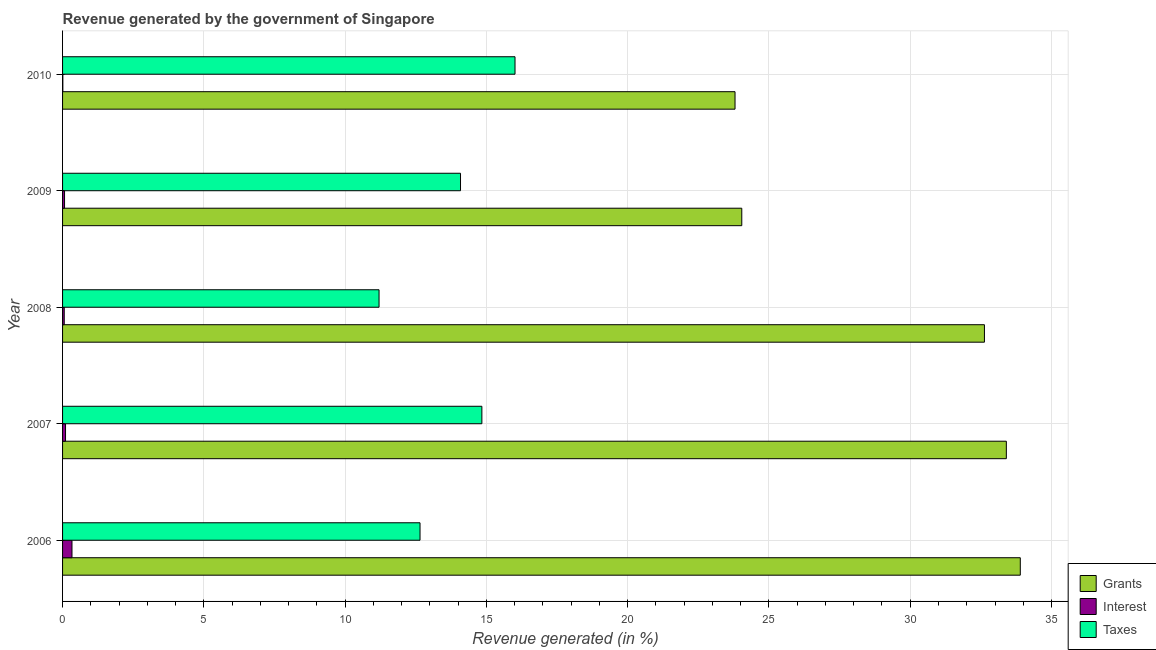How many different coloured bars are there?
Give a very brief answer. 3. What is the label of the 2nd group of bars from the top?
Give a very brief answer. 2009. What is the percentage of revenue generated by taxes in 2007?
Offer a very short reply. 14.84. Across all years, what is the maximum percentage of revenue generated by grants?
Offer a terse response. 33.89. Across all years, what is the minimum percentage of revenue generated by grants?
Make the answer very short. 23.8. In which year was the percentage of revenue generated by grants minimum?
Your answer should be compact. 2010. What is the total percentage of revenue generated by interest in the graph?
Provide a short and direct response. 0.58. What is the difference between the percentage of revenue generated by taxes in 2006 and that in 2010?
Provide a succinct answer. -3.36. What is the difference between the percentage of revenue generated by taxes in 2006 and the percentage of revenue generated by grants in 2008?
Your response must be concise. -19.98. What is the average percentage of revenue generated by grants per year?
Your answer should be very brief. 29.55. In the year 2010, what is the difference between the percentage of revenue generated by taxes and percentage of revenue generated by grants?
Provide a succinct answer. -7.79. In how many years, is the percentage of revenue generated by grants greater than 27 %?
Keep it short and to the point. 3. What is the ratio of the percentage of revenue generated by interest in 2007 to that in 2008?
Offer a terse response. 1.78. Is the percentage of revenue generated by interest in 2007 less than that in 2010?
Provide a succinct answer. No. What is the difference between the highest and the second highest percentage of revenue generated by grants?
Provide a short and direct response. 0.49. What is the difference between the highest and the lowest percentage of revenue generated by grants?
Your response must be concise. 10.1. In how many years, is the percentage of revenue generated by grants greater than the average percentage of revenue generated by grants taken over all years?
Keep it short and to the point. 3. Is the sum of the percentage of revenue generated by interest in 2009 and 2010 greater than the maximum percentage of revenue generated by taxes across all years?
Provide a short and direct response. No. What does the 3rd bar from the top in 2010 represents?
Your answer should be very brief. Grants. What does the 2nd bar from the bottom in 2008 represents?
Your answer should be compact. Interest. Are all the bars in the graph horizontal?
Ensure brevity in your answer.  Yes. How many years are there in the graph?
Offer a very short reply. 5. Does the graph contain any zero values?
Make the answer very short. No. Does the graph contain grids?
Provide a succinct answer. Yes. Where does the legend appear in the graph?
Your answer should be very brief. Bottom right. What is the title of the graph?
Keep it short and to the point. Revenue generated by the government of Singapore. What is the label or title of the X-axis?
Provide a short and direct response. Revenue generated (in %). What is the Revenue generated (in %) of Grants in 2006?
Provide a short and direct response. 33.89. What is the Revenue generated (in %) in Interest in 2006?
Provide a succinct answer. 0.33. What is the Revenue generated (in %) of Taxes in 2006?
Keep it short and to the point. 12.65. What is the Revenue generated (in %) of Grants in 2007?
Provide a succinct answer. 33.4. What is the Revenue generated (in %) in Interest in 2007?
Offer a very short reply. 0.1. What is the Revenue generated (in %) in Taxes in 2007?
Keep it short and to the point. 14.84. What is the Revenue generated (in %) of Grants in 2008?
Provide a short and direct response. 32.63. What is the Revenue generated (in %) of Interest in 2008?
Your response must be concise. 0.06. What is the Revenue generated (in %) in Taxes in 2008?
Your answer should be compact. 11.2. What is the Revenue generated (in %) in Grants in 2009?
Make the answer very short. 24.04. What is the Revenue generated (in %) in Interest in 2009?
Provide a short and direct response. 0.07. What is the Revenue generated (in %) in Taxes in 2009?
Provide a succinct answer. 14.08. What is the Revenue generated (in %) in Grants in 2010?
Make the answer very short. 23.8. What is the Revenue generated (in %) in Interest in 2010?
Provide a succinct answer. 0.01. What is the Revenue generated (in %) of Taxes in 2010?
Give a very brief answer. 16.01. Across all years, what is the maximum Revenue generated (in %) of Grants?
Your answer should be compact. 33.89. Across all years, what is the maximum Revenue generated (in %) of Interest?
Your response must be concise. 0.33. Across all years, what is the maximum Revenue generated (in %) of Taxes?
Provide a short and direct response. 16.01. Across all years, what is the minimum Revenue generated (in %) in Grants?
Keep it short and to the point. 23.8. Across all years, what is the minimum Revenue generated (in %) of Interest?
Make the answer very short. 0.01. Across all years, what is the minimum Revenue generated (in %) in Taxes?
Provide a succinct answer. 11.2. What is the total Revenue generated (in %) in Grants in the graph?
Ensure brevity in your answer.  147.76. What is the total Revenue generated (in %) in Interest in the graph?
Make the answer very short. 0.58. What is the total Revenue generated (in %) of Taxes in the graph?
Offer a very short reply. 68.79. What is the difference between the Revenue generated (in %) of Grants in 2006 and that in 2007?
Provide a short and direct response. 0.49. What is the difference between the Revenue generated (in %) of Interest in 2006 and that in 2007?
Your response must be concise. 0.23. What is the difference between the Revenue generated (in %) of Taxes in 2006 and that in 2007?
Give a very brief answer. -2.19. What is the difference between the Revenue generated (in %) of Grants in 2006 and that in 2008?
Your response must be concise. 1.27. What is the difference between the Revenue generated (in %) of Interest in 2006 and that in 2008?
Your answer should be very brief. 0.27. What is the difference between the Revenue generated (in %) of Taxes in 2006 and that in 2008?
Offer a terse response. 1.45. What is the difference between the Revenue generated (in %) of Grants in 2006 and that in 2009?
Ensure brevity in your answer.  9.86. What is the difference between the Revenue generated (in %) in Interest in 2006 and that in 2009?
Provide a short and direct response. 0.26. What is the difference between the Revenue generated (in %) in Taxes in 2006 and that in 2009?
Make the answer very short. -1.43. What is the difference between the Revenue generated (in %) in Grants in 2006 and that in 2010?
Ensure brevity in your answer.  10.1. What is the difference between the Revenue generated (in %) of Interest in 2006 and that in 2010?
Keep it short and to the point. 0.32. What is the difference between the Revenue generated (in %) in Taxes in 2006 and that in 2010?
Provide a succinct answer. -3.36. What is the difference between the Revenue generated (in %) of Grants in 2007 and that in 2008?
Your answer should be very brief. 0.78. What is the difference between the Revenue generated (in %) of Interest in 2007 and that in 2008?
Your answer should be compact. 0.05. What is the difference between the Revenue generated (in %) of Taxes in 2007 and that in 2008?
Provide a succinct answer. 3.64. What is the difference between the Revenue generated (in %) of Grants in 2007 and that in 2009?
Provide a short and direct response. 9.36. What is the difference between the Revenue generated (in %) of Interest in 2007 and that in 2009?
Provide a short and direct response. 0.03. What is the difference between the Revenue generated (in %) of Taxes in 2007 and that in 2009?
Provide a short and direct response. 0.76. What is the difference between the Revenue generated (in %) in Grants in 2007 and that in 2010?
Ensure brevity in your answer.  9.6. What is the difference between the Revenue generated (in %) in Interest in 2007 and that in 2010?
Provide a short and direct response. 0.09. What is the difference between the Revenue generated (in %) in Taxes in 2007 and that in 2010?
Offer a terse response. -1.17. What is the difference between the Revenue generated (in %) of Grants in 2008 and that in 2009?
Offer a terse response. 8.59. What is the difference between the Revenue generated (in %) in Interest in 2008 and that in 2009?
Your answer should be compact. -0.01. What is the difference between the Revenue generated (in %) in Taxes in 2008 and that in 2009?
Provide a short and direct response. -2.88. What is the difference between the Revenue generated (in %) in Grants in 2008 and that in 2010?
Your response must be concise. 8.83. What is the difference between the Revenue generated (in %) of Interest in 2008 and that in 2010?
Your response must be concise. 0.05. What is the difference between the Revenue generated (in %) of Taxes in 2008 and that in 2010?
Your answer should be compact. -4.81. What is the difference between the Revenue generated (in %) of Grants in 2009 and that in 2010?
Give a very brief answer. 0.24. What is the difference between the Revenue generated (in %) of Interest in 2009 and that in 2010?
Provide a succinct answer. 0.06. What is the difference between the Revenue generated (in %) in Taxes in 2009 and that in 2010?
Your answer should be compact. -1.93. What is the difference between the Revenue generated (in %) in Grants in 2006 and the Revenue generated (in %) in Interest in 2007?
Ensure brevity in your answer.  33.79. What is the difference between the Revenue generated (in %) in Grants in 2006 and the Revenue generated (in %) in Taxes in 2007?
Keep it short and to the point. 19.06. What is the difference between the Revenue generated (in %) of Interest in 2006 and the Revenue generated (in %) of Taxes in 2007?
Offer a terse response. -14.51. What is the difference between the Revenue generated (in %) in Grants in 2006 and the Revenue generated (in %) in Interest in 2008?
Offer a terse response. 33.84. What is the difference between the Revenue generated (in %) in Grants in 2006 and the Revenue generated (in %) in Taxes in 2008?
Keep it short and to the point. 22.69. What is the difference between the Revenue generated (in %) in Interest in 2006 and the Revenue generated (in %) in Taxes in 2008?
Make the answer very short. -10.87. What is the difference between the Revenue generated (in %) of Grants in 2006 and the Revenue generated (in %) of Interest in 2009?
Ensure brevity in your answer.  33.82. What is the difference between the Revenue generated (in %) in Grants in 2006 and the Revenue generated (in %) in Taxes in 2009?
Your answer should be compact. 19.81. What is the difference between the Revenue generated (in %) in Interest in 2006 and the Revenue generated (in %) in Taxes in 2009?
Offer a very short reply. -13.75. What is the difference between the Revenue generated (in %) in Grants in 2006 and the Revenue generated (in %) in Interest in 2010?
Your answer should be compact. 33.88. What is the difference between the Revenue generated (in %) in Grants in 2006 and the Revenue generated (in %) in Taxes in 2010?
Ensure brevity in your answer.  17.88. What is the difference between the Revenue generated (in %) in Interest in 2006 and the Revenue generated (in %) in Taxes in 2010?
Make the answer very short. -15.68. What is the difference between the Revenue generated (in %) of Grants in 2007 and the Revenue generated (in %) of Interest in 2008?
Make the answer very short. 33.34. What is the difference between the Revenue generated (in %) in Grants in 2007 and the Revenue generated (in %) in Taxes in 2008?
Your response must be concise. 22.2. What is the difference between the Revenue generated (in %) in Interest in 2007 and the Revenue generated (in %) in Taxes in 2008?
Ensure brevity in your answer.  -11.1. What is the difference between the Revenue generated (in %) of Grants in 2007 and the Revenue generated (in %) of Interest in 2009?
Offer a terse response. 33.33. What is the difference between the Revenue generated (in %) in Grants in 2007 and the Revenue generated (in %) in Taxes in 2009?
Your answer should be compact. 19.32. What is the difference between the Revenue generated (in %) in Interest in 2007 and the Revenue generated (in %) in Taxes in 2009?
Offer a terse response. -13.98. What is the difference between the Revenue generated (in %) in Grants in 2007 and the Revenue generated (in %) in Interest in 2010?
Provide a succinct answer. 33.39. What is the difference between the Revenue generated (in %) in Grants in 2007 and the Revenue generated (in %) in Taxes in 2010?
Give a very brief answer. 17.39. What is the difference between the Revenue generated (in %) in Interest in 2007 and the Revenue generated (in %) in Taxes in 2010?
Ensure brevity in your answer.  -15.91. What is the difference between the Revenue generated (in %) in Grants in 2008 and the Revenue generated (in %) in Interest in 2009?
Provide a succinct answer. 32.56. What is the difference between the Revenue generated (in %) in Grants in 2008 and the Revenue generated (in %) in Taxes in 2009?
Offer a very short reply. 18.54. What is the difference between the Revenue generated (in %) of Interest in 2008 and the Revenue generated (in %) of Taxes in 2009?
Make the answer very short. -14.03. What is the difference between the Revenue generated (in %) of Grants in 2008 and the Revenue generated (in %) of Interest in 2010?
Your answer should be compact. 32.62. What is the difference between the Revenue generated (in %) in Grants in 2008 and the Revenue generated (in %) in Taxes in 2010?
Your answer should be compact. 16.61. What is the difference between the Revenue generated (in %) in Interest in 2008 and the Revenue generated (in %) in Taxes in 2010?
Offer a terse response. -15.95. What is the difference between the Revenue generated (in %) in Grants in 2009 and the Revenue generated (in %) in Interest in 2010?
Provide a succinct answer. 24.03. What is the difference between the Revenue generated (in %) in Grants in 2009 and the Revenue generated (in %) in Taxes in 2010?
Give a very brief answer. 8.03. What is the difference between the Revenue generated (in %) in Interest in 2009 and the Revenue generated (in %) in Taxes in 2010?
Provide a succinct answer. -15.94. What is the average Revenue generated (in %) of Grants per year?
Ensure brevity in your answer.  29.55. What is the average Revenue generated (in %) in Interest per year?
Provide a succinct answer. 0.12. What is the average Revenue generated (in %) in Taxes per year?
Provide a succinct answer. 13.76. In the year 2006, what is the difference between the Revenue generated (in %) in Grants and Revenue generated (in %) in Interest?
Your answer should be very brief. 33.56. In the year 2006, what is the difference between the Revenue generated (in %) in Grants and Revenue generated (in %) in Taxes?
Provide a succinct answer. 21.24. In the year 2006, what is the difference between the Revenue generated (in %) of Interest and Revenue generated (in %) of Taxes?
Offer a very short reply. -12.32. In the year 2007, what is the difference between the Revenue generated (in %) in Grants and Revenue generated (in %) in Interest?
Provide a short and direct response. 33.3. In the year 2007, what is the difference between the Revenue generated (in %) in Grants and Revenue generated (in %) in Taxes?
Give a very brief answer. 18.56. In the year 2007, what is the difference between the Revenue generated (in %) in Interest and Revenue generated (in %) in Taxes?
Your answer should be compact. -14.73. In the year 2008, what is the difference between the Revenue generated (in %) of Grants and Revenue generated (in %) of Interest?
Ensure brevity in your answer.  32.57. In the year 2008, what is the difference between the Revenue generated (in %) of Grants and Revenue generated (in %) of Taxes?
Ensure brevity in your answer.  21.43. In the year 2008, what is the difference between the Revenue generated (in %) in Interest and Revenue generated (in %) in Taxes?
Provide a succinct answer. -11.14. In the year 2009, what is the difference between the Revenue generated (in %) of Grants and Revenue generated (in %) of Interest?
Ensure brevity in your answer.  23.97. In the year 2009, what is the difference between the Revenue generated (in %) of Grants and Revenue generated (in %) of Taxes?
Your answer should be compact. 9.95. In the year 2009, what is the difference between the Revenue generated (in %) in Interest and Revenue generated (in %) in Taxes?
Your response must be concise. -14.01. In the year 2010, what is the difference between the Revenue generated (in %) in Grants and Revenue generated (in %) in Interest?
Provide a short and direct response. 23.79. In the year 2010, what is the difference between the Revenue generated (in %) of Grants and Revenue generated (in %) of Taxes?
Your answer should be compact. 7.79. In the year 2010, what is the difference between the Revenue generated (in %) of Interest and Revenue generated (in %) of Taxes?
Keep it short and to the point. -16. What is the ratio of the Revenue generated (in %) of Grants in 2006 to that in 2007?
Provide a short and direct response. 1.01. What is the ratio of the Revenue generated (in %) in Interest in 2006 to that in 2007?
Your response must be concise. 3.18. What is the ratio of the Revenue generated (in %) in Taxes in 2006 to that in 2007?
Provide a short and direct response. 0.85. What is the ratio of the Revenue generated (in %) in Grants in 2006 to that in 2008?
Keep it short and to the point. 1.04. What is the ratio of the Revenue generated (in %) of Interest in 2006 to that in 2008?
Provide a succinct answer. 5.65. What is the ratio of the Revenue generated (in %) of Taxes in 2006 to that in 2008?
Your answer should be compact. 1.13. What is the ratio of the Revenue generated (in %) of Grants in 2006 to that in 2009?
Offer a terse response. 1.41. What is the ratio of the Revenue generated (in %) of Interest in 2006 to that in 2009?
Ensure brevity in your answer.  4.77. What is the ratio of the Revenue generated (in %) in Taxes in 2006 to that in 2009?
Keep it short and to the point. 0.9. What is the ratio of the Revenue generated (in %) of Grants in 2006 to that in 2010?
Your answer should be compact. 1.42. What is the ratio of the Revenue generated (in %) of Interest in 2006 to that in 2010?
Offer a terse response. 33.89. What is the ratio of the Revenue generated (in %) in Taxes in 2006 to that in 2010?
Your answer should be compact. 0.79. What is the ratio of the Revenue generated (in %) of Grants in 2007 to that in 2008?
Give a very brief answer. 1.02. What is the ratio of the Revenue generated (in %) in Interest in 2007 to that in 2008?
Provide a short and direct response. 1.78. What is the ratio of the Revenue generated (in %) in Taxes in 2007 to that in 2008?
Offer a terse response. 1.32. What is the ratio of the Revenue generated (in %) in Grants in 2007 to that in 2009?
Your answer should be compact. 1.39. What is the ratio of the Revenue generated (in %) of Interest in 2007 to that in 2009?
Your answer should be very brief. 1.5. What is the ratio of the Revenue generated (in %) of Taxes in 2007 to that in 2009?
Offer a terse response. 1.05. What is the ratio of the Revenue generated (in %) of Grants in 2007 to that in 2010?
Give a very brief answer. 1.4. What is the ratio of the Revenue generated (in %) of Interest in 2007 to that in 2010?
Your response must be concise. 10.64. What is the ratio of the Revenue generated (in %) of Taxes in 2007 to that in 2010?
Make the answer very short. 0.93. What is the ratio of the Revenue generated (in %) of Grants in 2008 to that in 2009?
Keep it short and to the point. 1.36. What is the ratio of the Revenue generated (in %) in Interest in 2008 to that in 2009?
Offer a very short reply. 0.84. What is the ratio of the Revenue generated (in %) in Taxes in 2008 to that in 2009?
Give a very brief answer. 0.8. What is the ratio of the Revenue generated (in %) of Grants in 2008 to that in 2010?
Ensure brevity in your answer.  1.37. What is the ratio of the Revenue generated (in %) of Interest in 2008 to that in 2010?
Provide a short and direct response. 6. What is the ratio of the Revenue generated (in %) of Taxes in 2008 to that in 2010?
Provide a short and direct response. 0.7. What is the ratio of the Revenue generated (in %) in Grants in 2009 to that in 2010?
Give a very brief answer. 1.01. What is the ratio of the Revenue generated (in %) in Interest in 2009 to that in 2010?
Provide a short and direct response. 7.1. What is the ratio of the Revenue generated (in %) of Taxes in 2009 to that in 2010?
Make the answer very short. 0.88. What is the difference between the highest and the second highest Revenue generated (in %) in Grants?
Keep it short and to the point. 0.49. What is the difference between the highest and the second highest Revenue generated (in %) of Interest?
Ensure brevity in your answer.  0.23. What is the difference between the highest and the second highest Revenue generated (in %) in Taxes?
Provide a succinct answer. 1.17. What is the difference between the highest and the lowest Revenue generated (in %) in Grants?
Offer a terse response. 10.1. What is the difference between the highest and the lowest Revenue generated (in %) in Interest?
Provide a short and direct response. 0.32. What is the difference between the highest and the lowest Revenue generated (in %) in Taxes?
Ensure brevity in your answer.  4.81. 